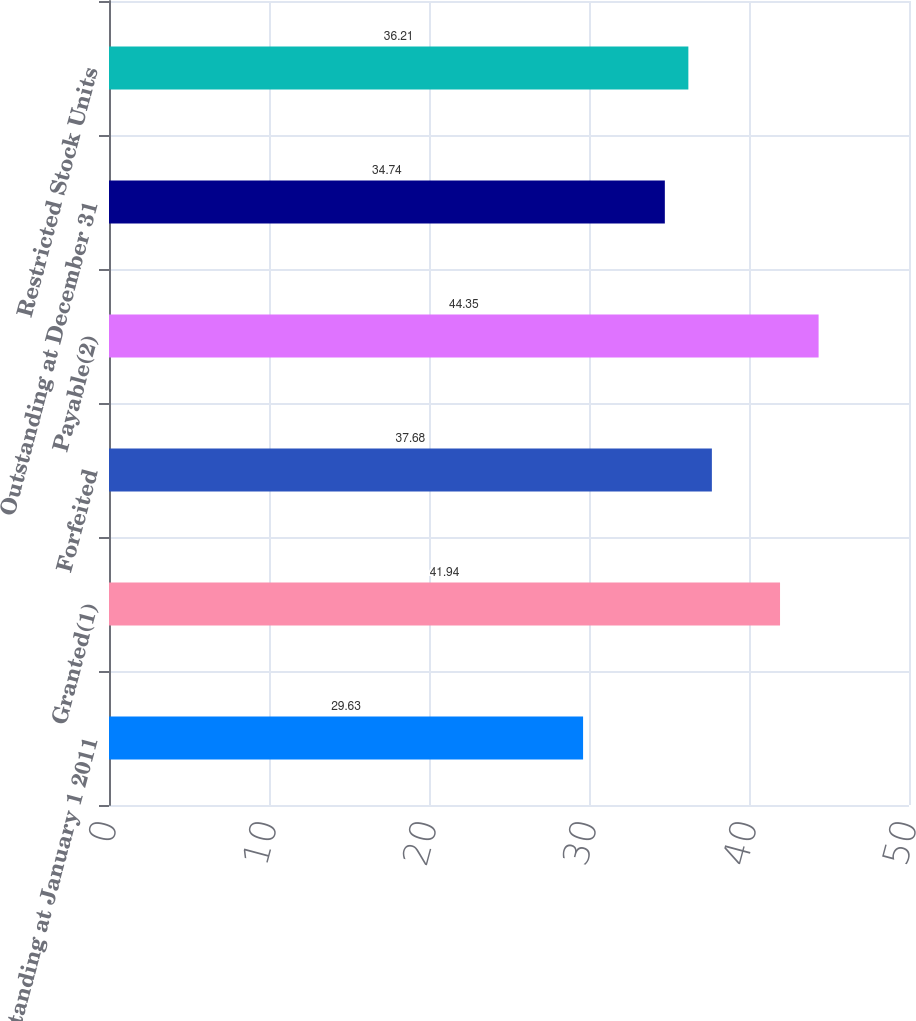Convert chart to OTSL. <chart><loc_0><loc_0><loc_500><loc_500><bar_chart><fcel>Outstanding at January 1 2011<fcel>Granted(1)<fcel>Forfeited<fcel>Payable(2)<fcel>Outstanding at December 31<fcel>Restricted Stock Units<nl><fcel>29.63<fcel>41.94<fcel>37.68<fcel>44.35<fcel>34.74<fcel>36.21<nl></chart> 